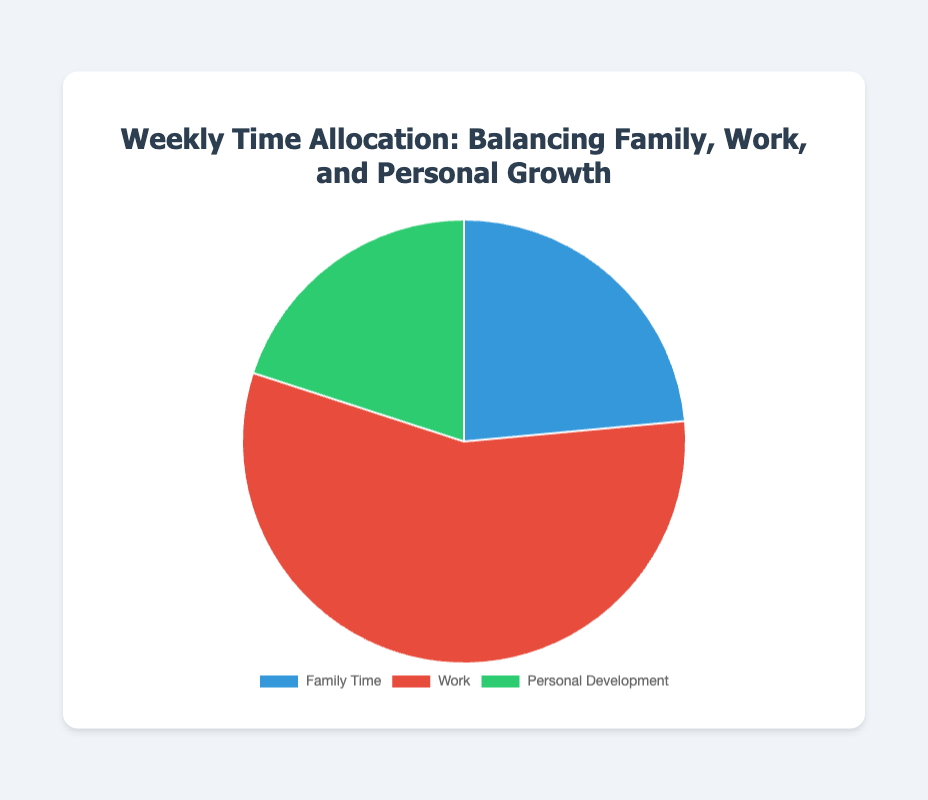What percentage of the week is allocated to 'Work'? By looking at the pie chart, identify the segment labeled 'Work' and refer to the tooltip or legend for its percentage. The tooltip indicates that 'Work' consists of 48 hours. Since there are 80 hours in total, the percentage is (48/80) * 100 = 60%.
Answer: 60% How many more hours per week are allocated to 'Work' compared to 'Family Time'? Identify the total hours for 'Work' and 'Family Time' from the chart. Work has 48 hours and Family Time has 20 hours. The difference is 48 - 20 = 28 hours.
Answer: 28 hours Which category has the smallest allocation and how many hours is it? Find the smallest segment in the pie chart which is 'Personal Development'. The tooltip indicates that it consists of 17 hours.
Answer: Personal Development, 17 hours What is the combined total number of hours for 'Family Time' and 'Personal Development'? Sum the hours for 'Family Time' (20) and 'Personal Development' (17) to get 20 + 17 = 37 hours.
Answer: 37 hours Are the hours for 'Family Time' greater than or less than those for 'Personal Development'? Compare the total hours for 'Family Time' and 'Personal Development'. Family Time has 20 hours and Personal Development has 17 hours. Since 20 is greater than 17, Family Time has more hours.
Answer: Greater than If you were to add the hours spent on 'Personal Development' and 'Family Time', how would it compare with 'Work'? Add the hours for Personal Development (17) and Family Time (20) to get 37 hours. Compare this sum with Work (48 hours). 37 is less than 48.
Answer: Less than Among the categories, which has the largest chunk, and what activities belong to it? The largest segment by area/size in the pie chart is the 'Work' segment. The tooltip indicates the activities under 'Work' are Office hours, Networking events, and Business meetings.
Answer: Work (Office hours, Networking events, Business meetings) How much time in total is spent on 'Work' activities on a weekly basis? The pie chart shows that 'Work' is constituted by three activities: Office hours (40), Networking events (3), and Business meetings (5). Sum these up to get 40 + 3 + 5 = 48 hours.
Answer: 48 hours What do the different colors in the pie chart represent? Each color in the pie chart represents a different category of activities. The colors and their corresponding categories can be seen in the legend: blue for Work, red for Family Time, and green for Personal Development.
Answer: Blue: Work, Red: Family Time, Green: Personal Development 